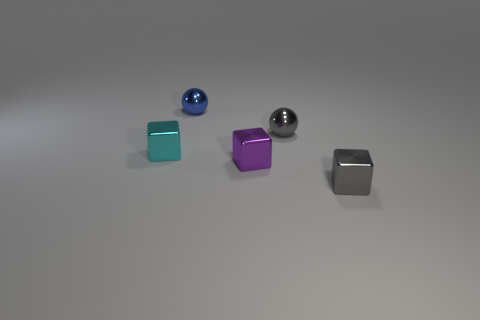What is the tiny gray block made of?
Keep it short and to the point. Metal. There is a purple thing; is it the same shape as the metal thing left of the blue object?
Make the answer very short. Yes. The small cube that is to the left of the purple block that is in front of the tiny gray shiny thing behind the small cyan metallic block is made of what material?
Offer a terse response. Metal. How many large blue rubber balls are there?
Your answer should be compact. 0. How many cyan things are either tiny metallic blocks or tiny rubber balls?
Provide a succinct answer. 1. How many other things are there of the same shape as the tiny blue metallic object?
Provide a short and direct response. 1. There is a object that is in front of the small purple thing; is its color the same as the small ball to the right of the tiny blue ball?
Make the answer very short. Yes. What number of large objects are either green matte cylinders or blue balls?
Your response must be concise. 0. The cyan metallic object that is the same shape as the purple object is what size?
Ensure brevity in your answer.  Small. What number of metal things are tiny yellow things or purple cubes?
Offer a terse response. 1. 